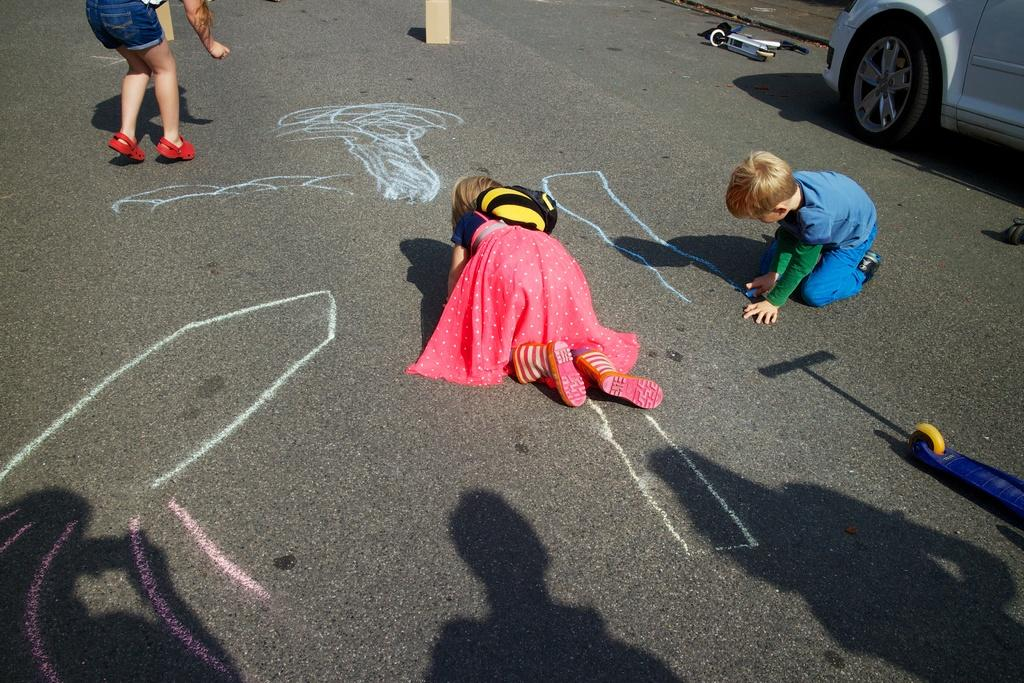Who is present in the image? There are children in the image. What are the children doing in the image? The children are writing on the road. Can you describe any other objects or elements in the image? There is a vehicle in the top right corner of the image. What type of fowl can be seen rolling on the road in the image? There is no fowl present in the image, and therefore no such activity can be observed. 